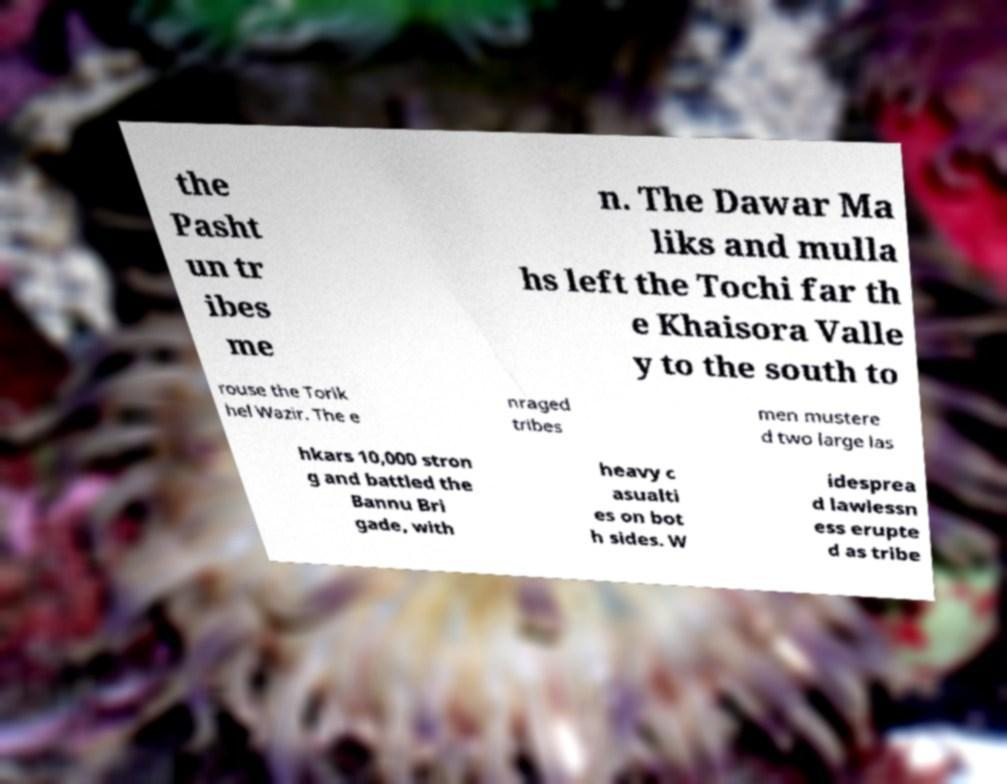What messages or text are displayed in this image? I need them in a readable, typed format. the Pasht un tr ibes me n. The Dawar Ma liks and mulla hs left the Tochi far th e Khaisora Valle y to the south to rouse the Torik hel Wazir. The e nraged tribes men mustere d two large las hkars 10,000 stron g and battled the Bannu Bri gade, with heavy c asualti es on bot h sides. W idesprea d lawlessn ess erupte d as tribe 